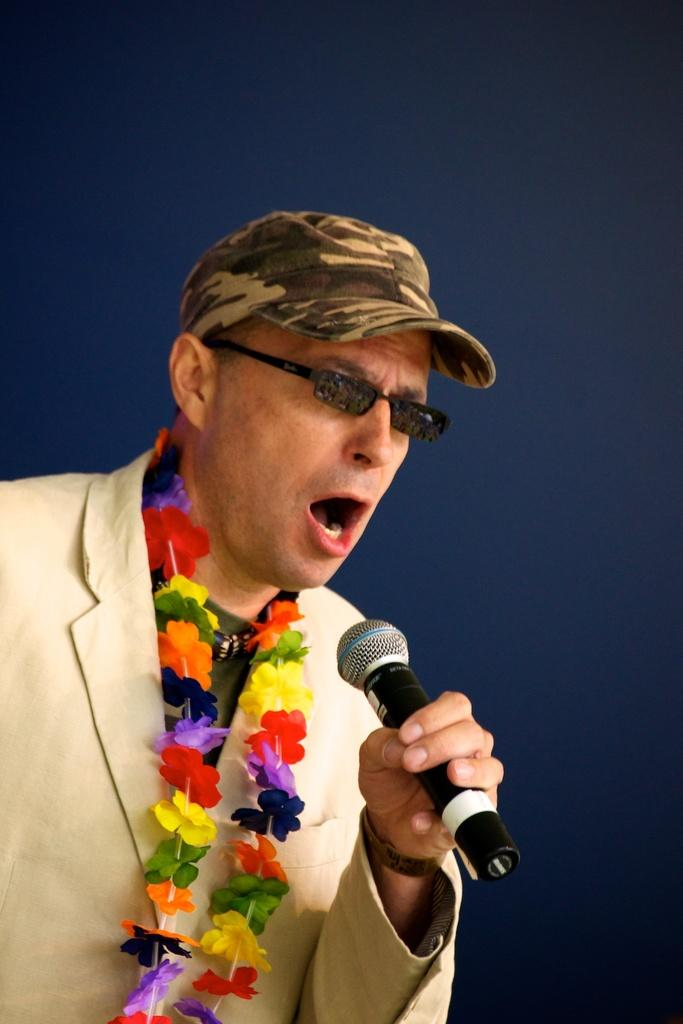What is the man in the image wearing? The man is wearing a suit and glasses. What is the man holding in the image? The man is holding a microphone. What is the man doing in the image? The man is singing. What is the man wearing around his neck in the image? The man is wearing a garland. What can be seen in the background of the image? There is a wall in the background of the image. What type of fork is the man using to eat in the image? There is no fork present in the image; the man is singing and holding a microphone. 